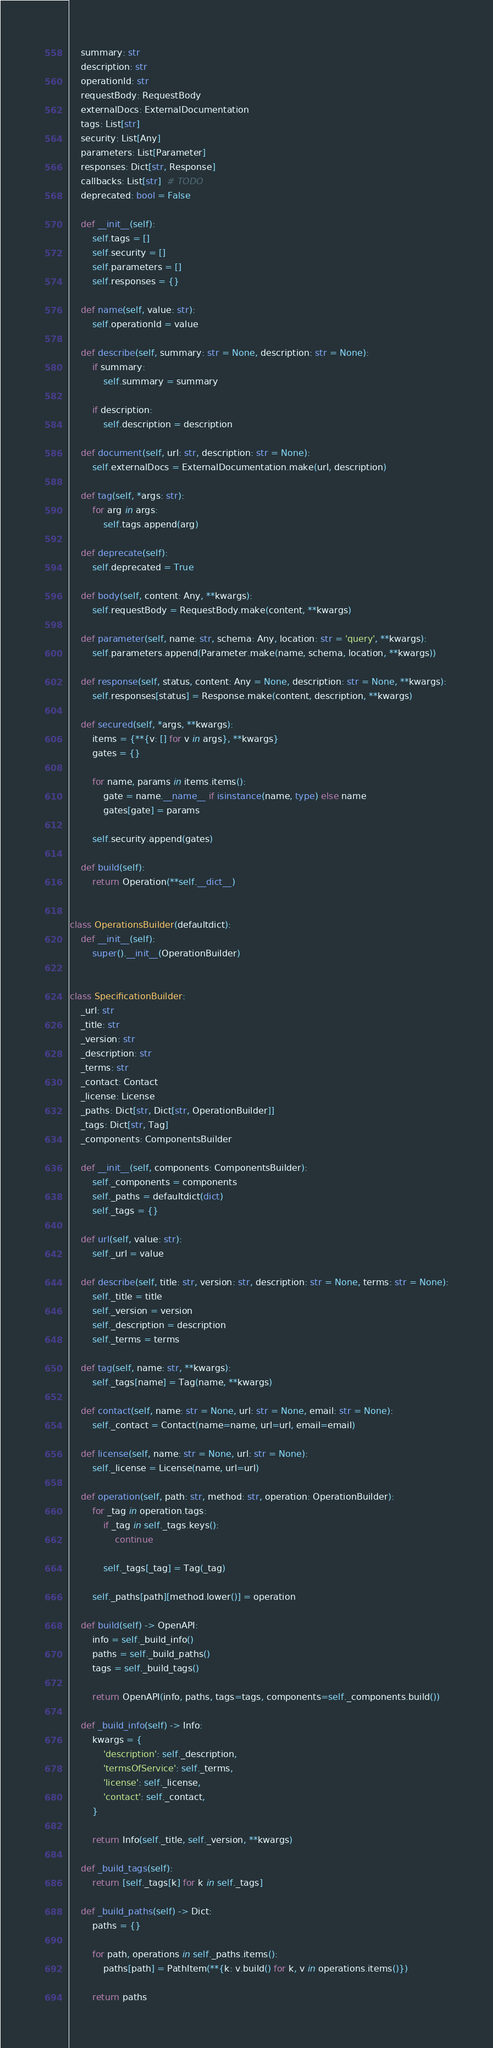<code> <loc_0><loc_0><loc_500><loc_500><_Python_>    summary: str
    description: str
    operationId: str
    requestBody: RequestBody
    externalDocs: ExternalDocumentation
    tags: List[str]
    security: List[Any]
    parameters: List[Parameter]
    responses: Dict[str, Response]
    callbacks: List[str]  # TODO
    deprecated: bool = False

    def __init__(self):
        self.tags = []
        self.security = []
        self.parameters = []
        self.responses = {}

    def name(self, value: str):
        self.operationId = value

    def describe(self, summary: str = None, description: str = None):
        if summary:
            self.summary = summary

        if description:
            self.description = description

    def document(self, url: str, description: str = None):
        self.externalDocs = ExternalDocumentation.make(url, description)

    def tag(self, *args: str):
        for arg in args:
            self.tags.append(arg)

    def deprecate(self):
        self.deprecated = True

    def body(self, content: Any, **kwargs):
        self.requestBody = RequestBody.make(content, **kwargs)

    def parameter(self, name: str, schema: Any, location: str = 'query', **kwargs):
        self.parameters.append(Parameter.make(name, schema, location, **kwargs))

    def response(self, status, content: Any = None, description: str = None, **kwargs):
        self.responses[status] = Response.make(content, description, **kwargs)

    def secured(self, *args, **kwargs):
        items = {**{v: [] for v in args}, **kwargs}
        gates = {}

        for name, params in items.items():
            gate = name.__name__ if isinstance(name, type) else name
            gates[gate] = params

        self.security.append(gates)

    def build(self):
        return Operation(**self.__dict__)


class OperationsBuilder(defaultdict):
    def __init__(self):
        super().__init__(OperationBuilder)


class SpecificationBuilder:
    _url: str
    _title: str
    _version: str
    _description: str
    _terms: str
    _contact: Contact
    _license: License
    _paths: Dict[str, Dict[str, OperationBuilder]]
    _tags: Dict[str, Tag]
    _components: ComponentsBuilder

    def __init__(self, components: ComponentsBuilder):
        self._components = components
        self._paths = defaultdict(dict)
        self._tags = {}

    def url(self, value: str):
        self._url = value

    def describe(self, title: str, version: str, description: str = None, terms: str = None):
        self._title = title
        self._version = version
        self._description = description
        self._terms = terms

    def tag(self, name: str, **kwargs):
        self._tags[name] = Tag(name, **kwargs)

    def contact(self, name: str = None, url: str = None, email: str = None):
        self._contact = Contact(name=name, url=url, email=email)

    def license(self, name: str = None, url: str = None):
        self._license = License(name, url=url)

    def operation(self, path: str, method: str, operation: OperationBuilder):
        for _tag in operation.tags:
            if _tag in self._tags.keys():
                continue

            self._tags[_tag] = Tag(_tag)

        self._paths[path][method.lower()] = operation

    def build(self) -> OpenAPI:
        info = self._build_info()
        paths = self._build_paths()
        tags = self._build_tags()

        return OpenAPI(info, paths, tags=tags, components=self._components.build())

    def _build_info(self) -> Info:
        kwargs = {
            'description': self._description,
            'termsOfService': self._terms,
            'license': self._license,
            'contact': self._contact,
        }

        return Info(self._title, self._version, **kwargs)

    def _build_tags(self):
        return [self._tags[k] for k in self._tags]

    def _build_paths(self) -> Dict:
        paths = {}

        for path, operations in self._paths.items():
            paths[path] = PathItem(**{k: v.build() for k, v in operations.items()})

        return paths
</code> 